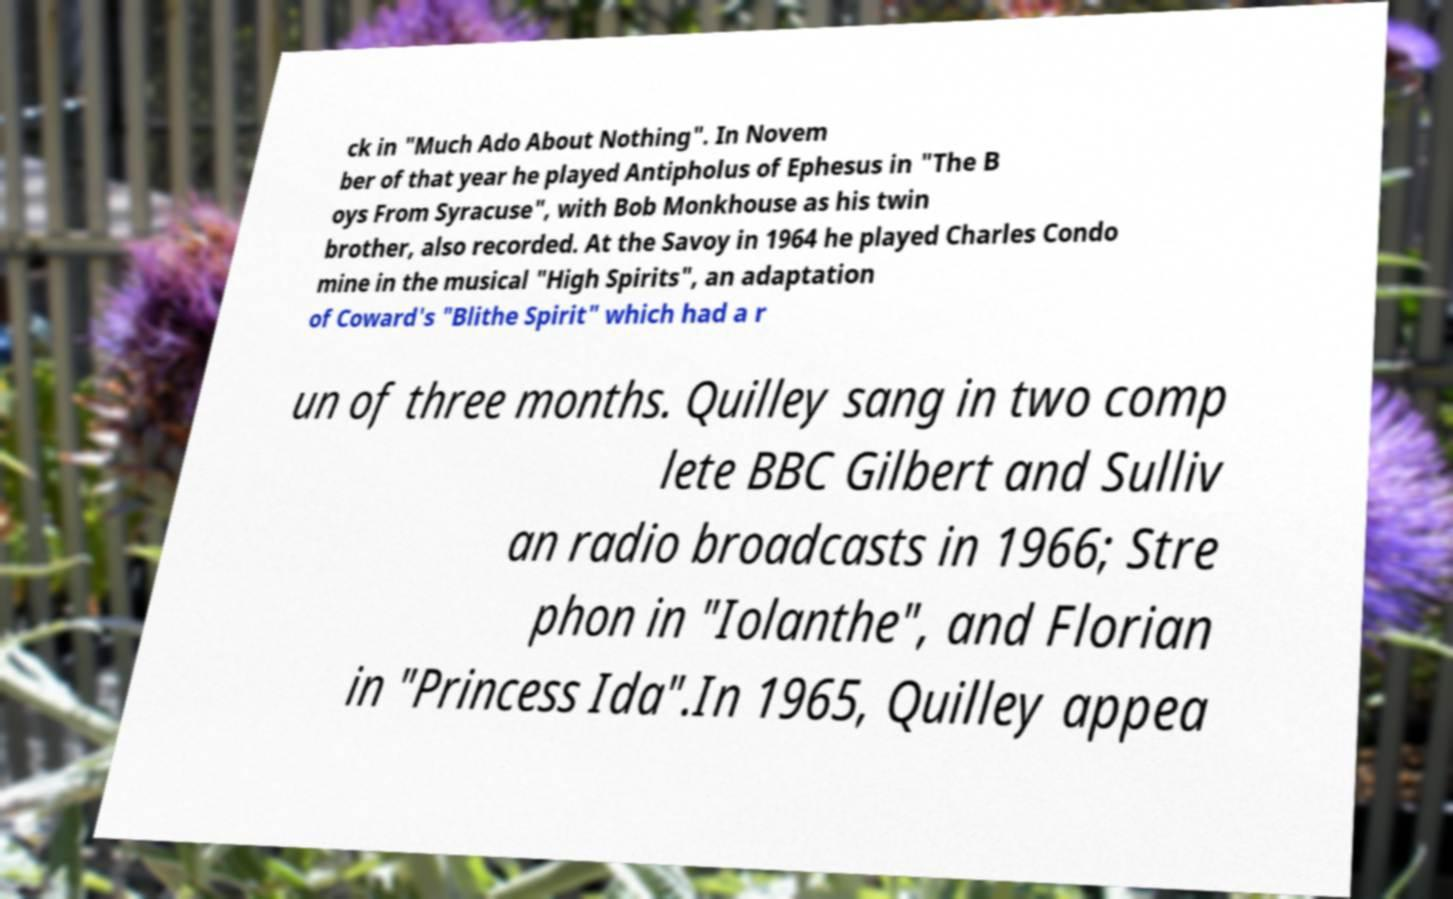Please identify and transcribe the text found in this image. ck in "Much Ado About Nothing". In Novem ber of that year he played Antipholus of Ephesus in "The B oys From Syracuse", with Bob Monkhouse as his twin brother, also recorded. At the Savoy in 1964 he played Charles Condo mine in the musical "High Spirits", an adaptation of Coward's "Blithe Spirit" which had a r un of three months. Quilley sang in two comp lete BBC Gilbert and Sulliv an radio broadcasts in 1966; Stre phon in "Iolanthe", and Florian in "Princess Ida".In 1965, Quilley appea 